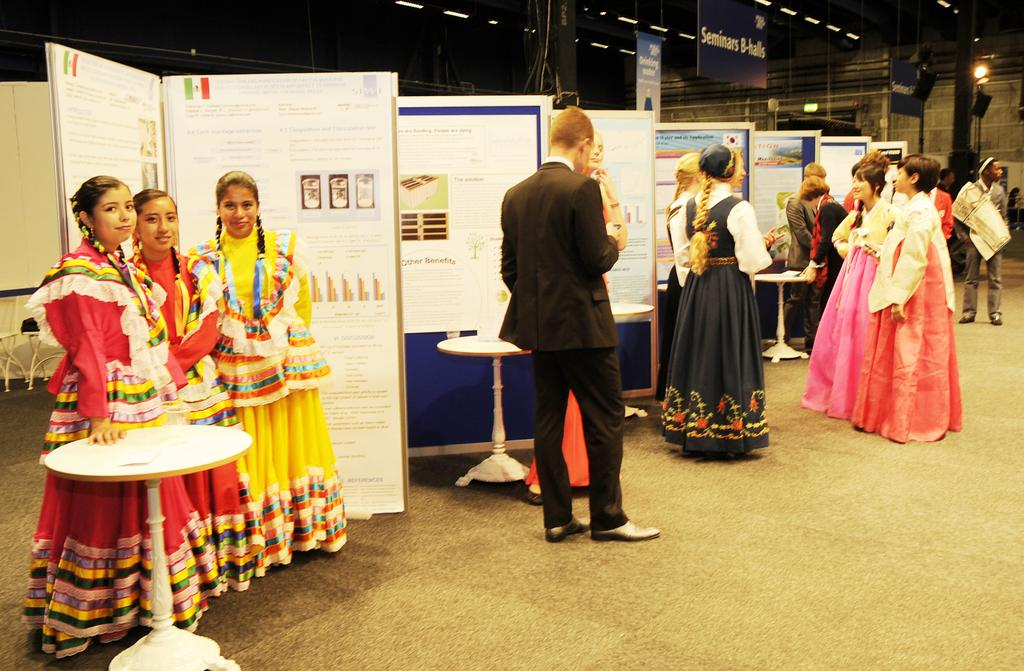How many people are in the room in the image? There are many people standing in the room. Can you describe any specific person in the room? There is a man wearing a black blazer in the room. What is one feature of the room that can be seen in the image? There is a display board in the room. What type of furniture is present in the room? There are tables in the room. What type of silk fabric is draped over the ball in the image? There is no ball or silk fabric present in the image. 